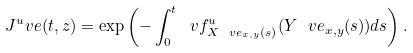Convert formula to latex. <formula><loc_0><loc_0><loc_500><loc_500>J ^ { u } _ { \ } v e ( t , z ) = \exp \left ( - \int _ { 0 } ^ { t } \ v f ^ { u } _ { X ^ { \ } v e _ { x , y } ( s ) } ( Y ^ { \ } v e _ { x , y } ( s ) ) d s \right ) .</formula> 